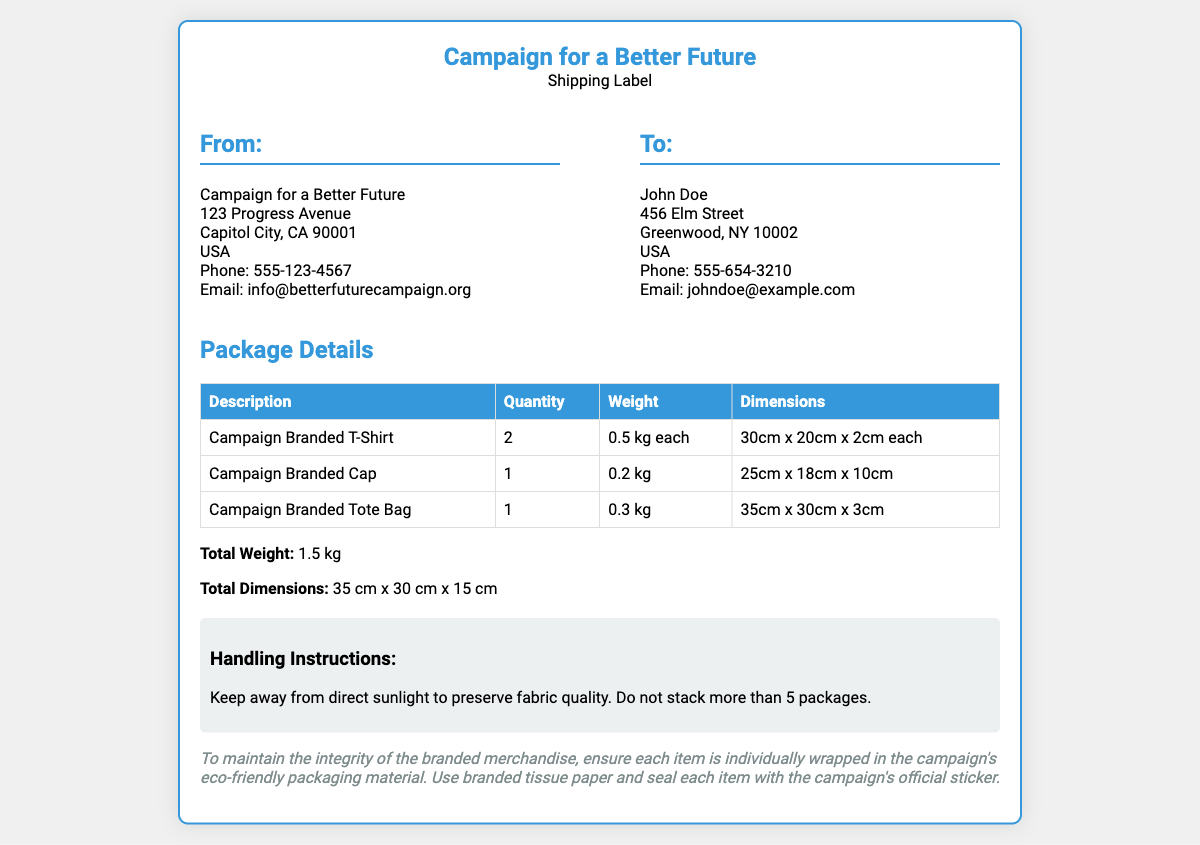What is the total weight of the package? The total weight is calculated by adding the weight of all items listed in the package details; two T-shirts at 0.5 kg each, one cap at 0.2 kg, and one tote bag at 0.3 kg equals 1.5 kg.
Answer: 1.5 kg What is the email address of the sender? The email address of the sender is provided in the address section for "From: Campaign for a Better Future."
Answer: info@betterfuturecampaign.org How many Campaign Branded T-Shirts are included? The quantity of Campaign Branded T-Shirts is listed in the package details table under the relevant description, which states there are 2 of them.
Answer: 2 What is the address of the recipient? The Recipient's address is listed under "To:" and contains all specified details including name, street, city, state, and zip code.
Answer: John Doe, 456 Elm Street, Greenwood, NY 10002, USA What should be kept away from direct sunlight? The handling instructions suggest that items should be kept away from direct sunlight to maintain their quality.
Answer: Items What type of packaging material is recommended? The document specifies that eco-friendly packaging material is recommended for maintaining brand integrity.
Answer: Eco-friendly packaging material What is the dimension of the Campaign Branded Cap? The dimensions for the Campaign Branded Cap are provided in the package details and are listed as 25 cm x 18 cm x 10 cm.
Answer: 25cm x 18cm x 10cm How many packages can be stacked? The handling instructions specify the maximum limit for stacking packages to prevent damage and ensure integrity.
Answer: 5 packages What must each item be wrapped in? To ensure brand integrity, the document specifies that each item must be individually wrapped in the campaign's eco-friendly packaging.
Answer: Eco-friendly packaging 